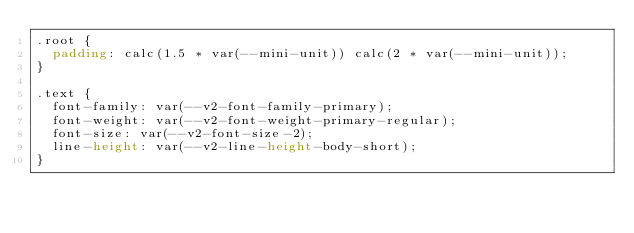Convert code to text. <code><loc_0><loc_0><loc_500><loc_500><_CSS_>.root {
  padding: calc(1.5 * var(--mini-unit)) calc(2 * var(--mini-unit));
}

.text {
  font-family: var(--v2-font-family-primary);
  font-weight: var(--v2-font-weight-primary-regular);
  font-size: var(--v2-font-size-2);
  line-height: var(--v2-line-height-body-short);
}
</code> 